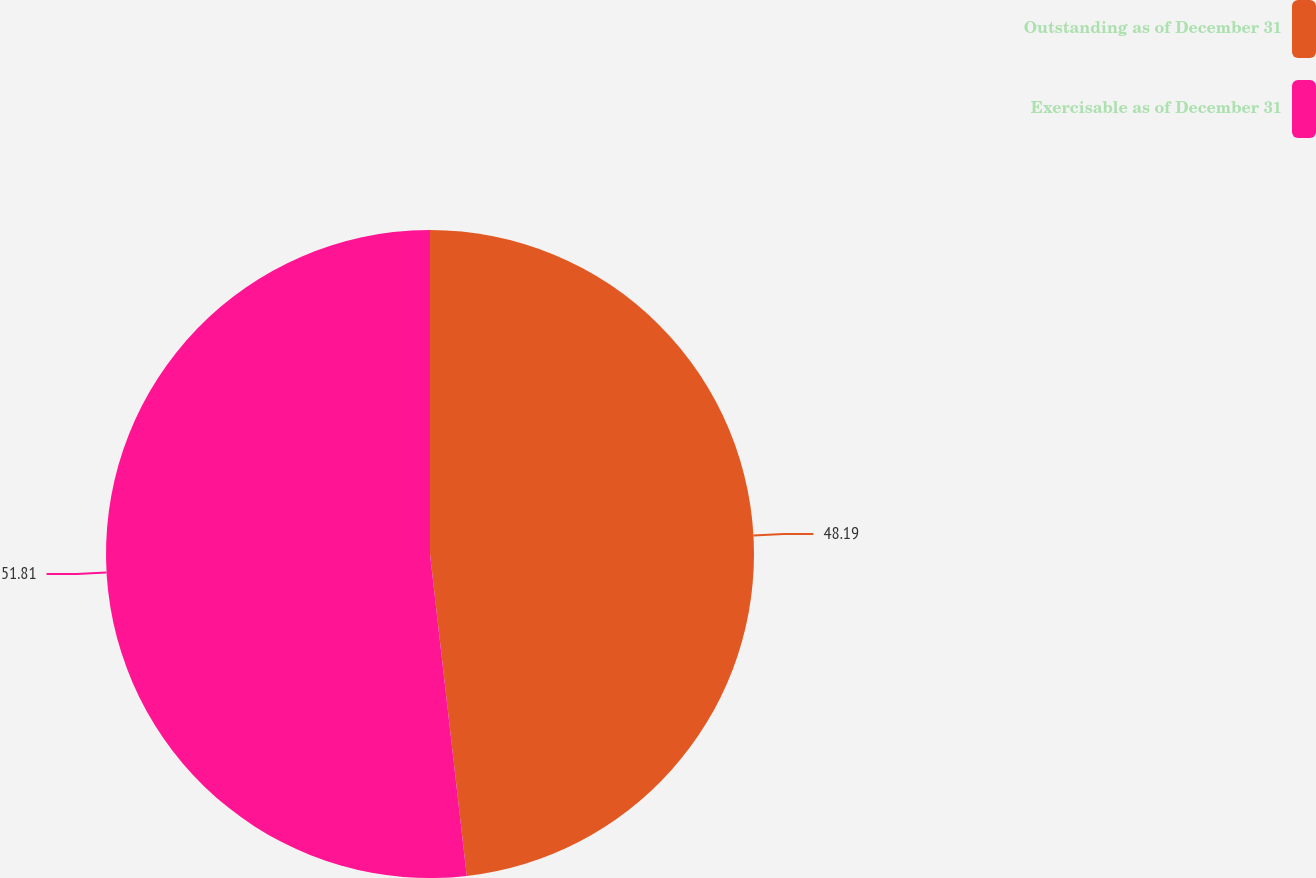Convert chart. <chart><loc_0><loc_0><loc_500><loc_500><pie_chart><fcel>Outstanding as of December 31<fcel>Exercisable as of December 31<nl><fcel>48.19%<fcel>51.81%<nl></chart> 